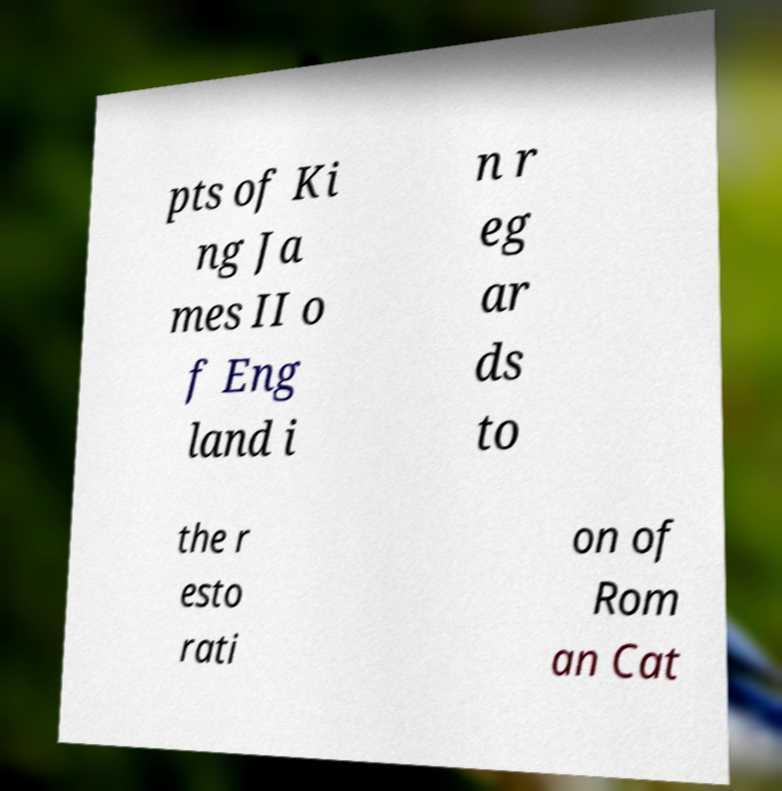Could you assist in decoding the text presented in this image and type it out clearly? pts of Ki ng Ja mes II o f Eng land i n r eg ar ds to the r esto rati on of Rom an Cat 